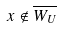Convert formula to latex. <formula><loc_0><loc_0><loc_500><loc_500>x \notin \overline { W _ { U } }</formula> 